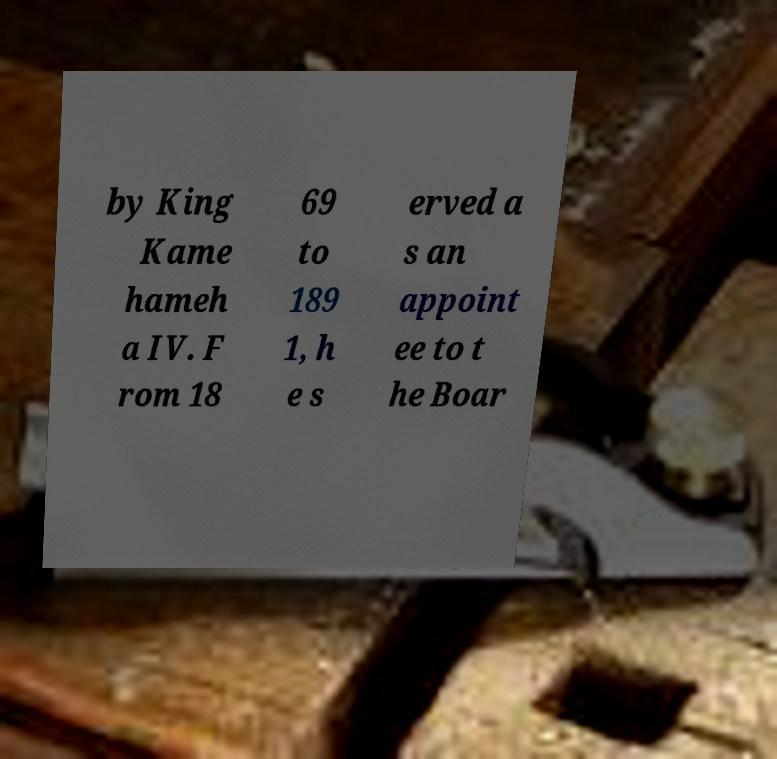Could you extract and type out the text from this image? by King Kame hameh a IV. F rom 18 69 to 189 1, h e s erved a s an appoint ee to t he Boar 